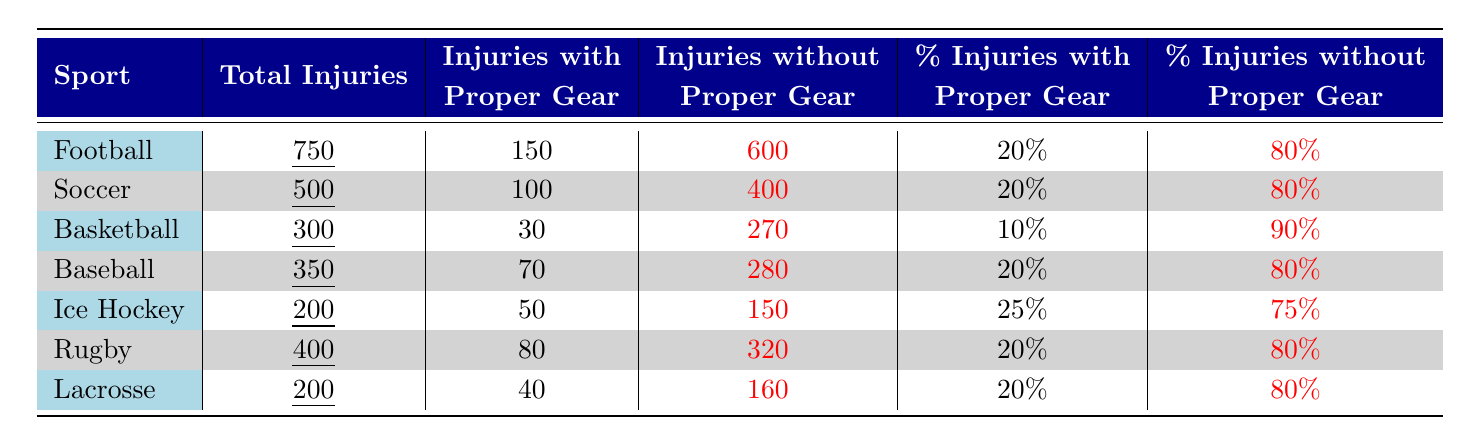What sport has the highest number of total injuries? The table shows that Football has a total of 750 injuries, which is the highest among all sports listed.
Answer: Football What is the percentage of injuries without proper gear in basketball? The table indicates that basketball has 90% of its injuries occurring without proper gear.
Answer: 90% How many injuries in soccer occurred with proper gear? According to the table, Soccer had 100 injuries with proper gear.
Answer: 100 Which sport has the lowest total injuries? The table shows that Ice Hockey and Lacrosse both have 200 total injuries, making them the sports with the lowest total injuries.
Answer: Ice Hockey and Lacrosse What is the total number of injuries across all sports listed? By adding up the total injuries for each sport (750 + 500 + 300 + 350 + 200 + 400 + 200), the total comes to 2900 injuries across all sports.
Answer: 2900 What percentage of injuries without proper gear is observed in Rugby? The table indicates that 80% of injuries in Rugby occurred without proper gear.
Answer: 80% In which sport is the percentage of injuries with proper gear the highest? Upon examining the table, Ice Hockey has the highest percentage of injuries with proper gear at 25%.
Answer: Ice Hockey How many more injuries occurred without proper gear in Football compared to Lacrosse? Football had 600 injuries without proper gear whereas Lacrosse had 160, so the difference is (600 - 160 = 440).
Answer: 440 If a sport had 400 total injuries and 20% were with proper gear, how many injuries occurred with proper gear? 20% of 400 injuries is calculated as (0.20 * 400 = 80), which matches the data presented for Rugby in the table.
Answer: 80 True or False: More than half of the total injuries in Baseball occurred with proper gear. The table shows that Baseball had 70 injuries with proper gear out of 350 total injuries, which is less than half (70 < 175).
Answer: False 